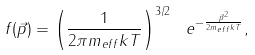Convert formula to latex. <formula><loc_0><loc_0><loc_500><loc_500>f ( \vec { p } ) = \left ( \frac { 1 } { 2 \pi m _ { e f f } k T } \right ) ^ { 3 / 2 } \ e ^ { - \frac { \vec { p } ^ { 2 } } { 2 m _ { e f f } k T } } ,</formula> 